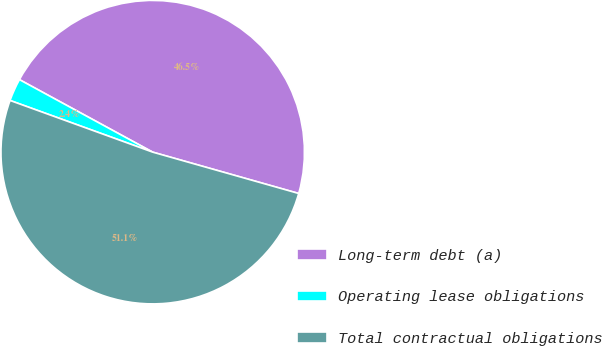Convert chart to OTSL. <chart><loc_0><loc_0><loc_500><loc_500><pie_chart><fcel>Long-term debt (a)<fcel>Operating lease obligations<fcel>Total contractual obligations<nl><fcel>46.46%<fcel>2.4%<fcel>51.14%<nl></chart> 